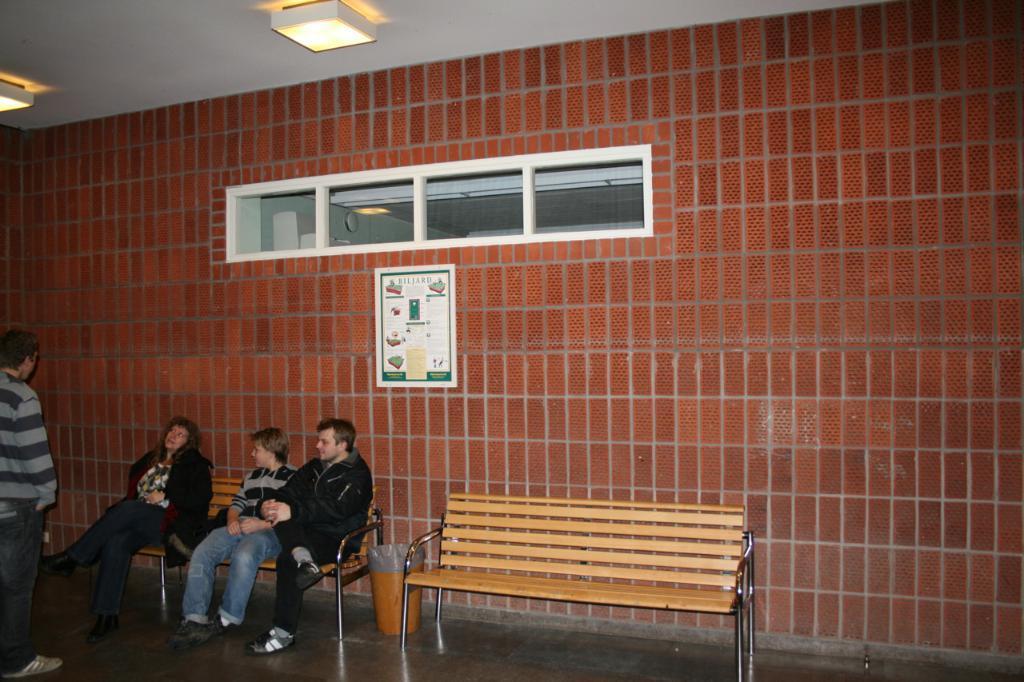How would you summarize this image in a sentence or two? This image is clicked in a room. There are four people in this image. In the middle, there is a empty bench. To the left, the man is standing. In the background there is a ventilator and a poster on the wall. At the top, there is a slab and light on it. 